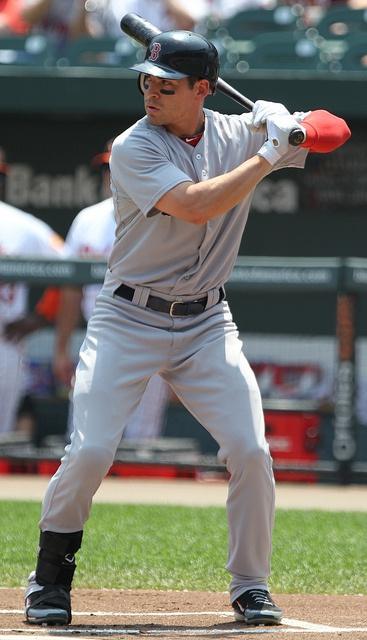Describe the objects in this image and their specific colors. I can see people in brown, darkgray, gray, and black tones, people in brown, lavender, gray, and darkgray tones, people in brown, white, darkgray, and gray tones, and baseball bat in brown, black, white, gray, and darkgray tones in this image. 